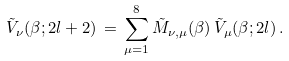<formula> <loc_0><loc_0><loc_500><loc_500>\tilde { V } _ { \nu } ( \beta ; 2 l + 2 ) \, = \, \sum _ { \mu = 1 } ^ { 8 } \tilde { M } _ { \nu , \mu } ( \beta ) \, \tilde { V } _ { \mu } ( \beta ; 2 l ) \, .</formula> 